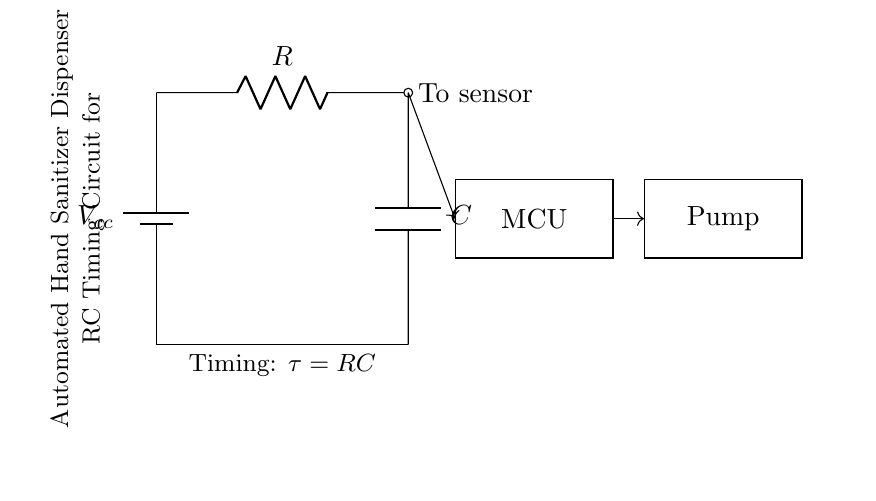What is the role of the capacitor in this circuit? The capacitor stores electrical energy and releases it during the timing cycle. It charges through the resistor, which determines the timing interval for the hand sanitizer dispenser's operation.
Answer: store energy What components are present in the circuit? The circuit consists of a battery, a resistor, a capacitor, a microcontroller unit (MCU), and a pump. Each component has a specific function in the timing mechanism for the dispenser.
Answer: battery, resistor, capacitor, MCU, pump What is the time constant of this RC circuit? The time constant (tau) is calculated as the product of the resistance (R) and capacitance (C), represented by the formula τ = R*C. This determines how quickly the capacitor charges and discharges.
Answer: RC Which component is connected to the sensor? The resistor is directly connected to the sensor, indicating that it is pivotal in controlling the timing signal that activates the MCU for dispensing hand sanitizer.
Answer: resistor How does the circuit initiate the sanitizer pump? The sensor detects the presence of a hand. Upon activation, the MCU receives this signal, which prompts it to control the pump for dispensing sanitizer, demonstrating an automatic response mechanism.
Answer: MCU What is the function of the microcontroller (MCU) in this circuit? The MCU processes the signal from the sensor and controls the operation of the pump based on the timing set by the RC components. It acts as the central control unit.
Answer: control unit 